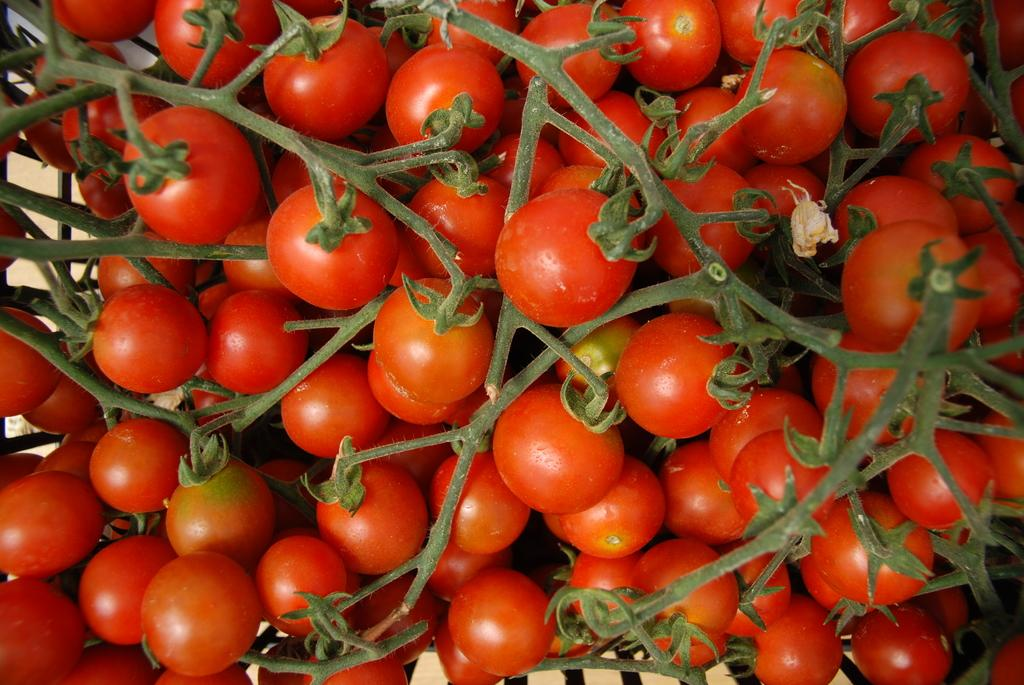What type of food is prominently featured in the image? There are many tomatoes in the image. Can you describe the quantity of tomatoes in the image? The image features a large number of tomatoes. What might someone do with the tomatoes in the image? Someone might use the tomatoes for cooking, making a salad, or preserving them. What type of flag is visible in the image? There is no flag present in the image; it features tomatoes. Can you describe the airport in the image? There is no airport present in the image; it features tomatoes. 